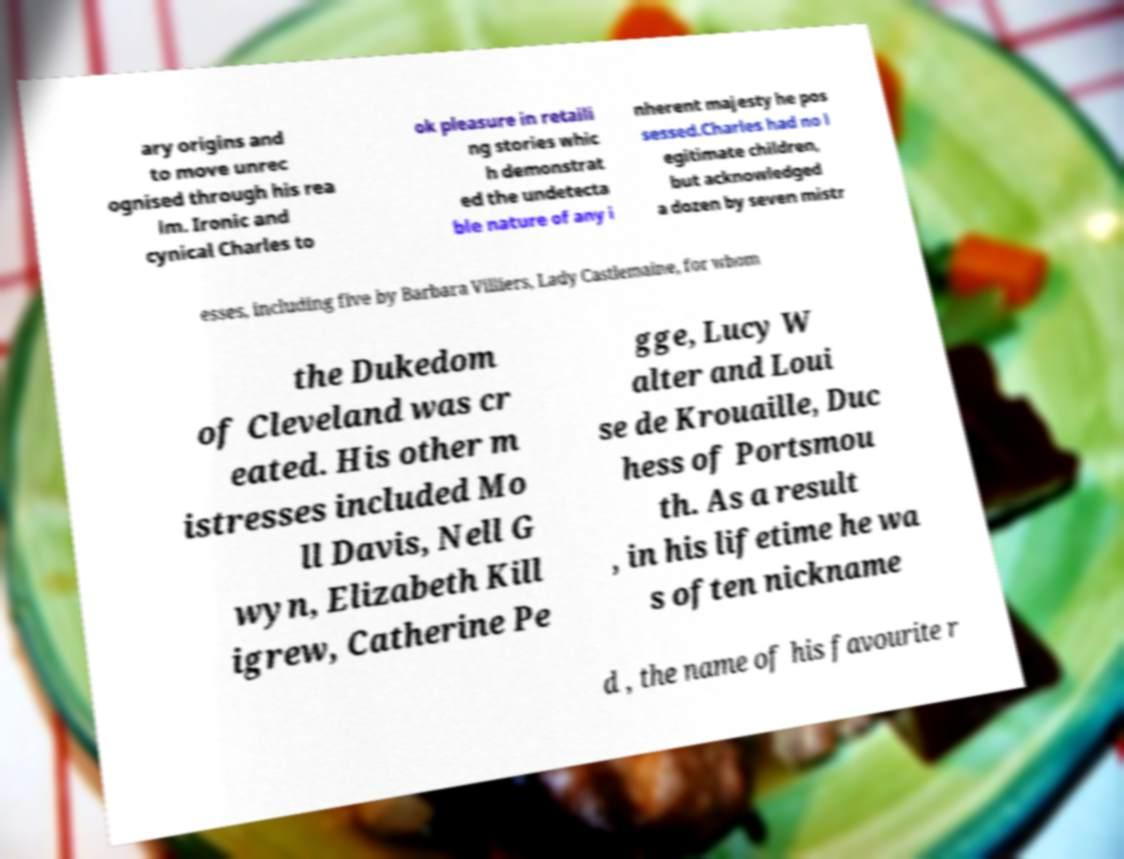Could you assist in decoding the text presented in this image and type it out clearly? ary origins and to move unrec ognised through his rea lm. Ironic and cynical Charles to ok pleasure in retaili ng stories whic h demonstrat ed the undetecta ble nature of any i nherent majesty he pos sessed.Charles had no l egitimate children, but acknowledged a dozen by seven mistr esses, including five by Barbara Villiers, Lady Castlemaine, for whom the Dukedom of Cleveland was cr eated. His other m istresses included Mo ll Davis, Nell G wyn, Elizabeth Kill igrew, Catherine Pe gge, Lucy W alter and Loui se de Krouaille, Duc hess of Portsmou th. As a result , in his lifetime he wa s often nickname d , the name of his favourite r 